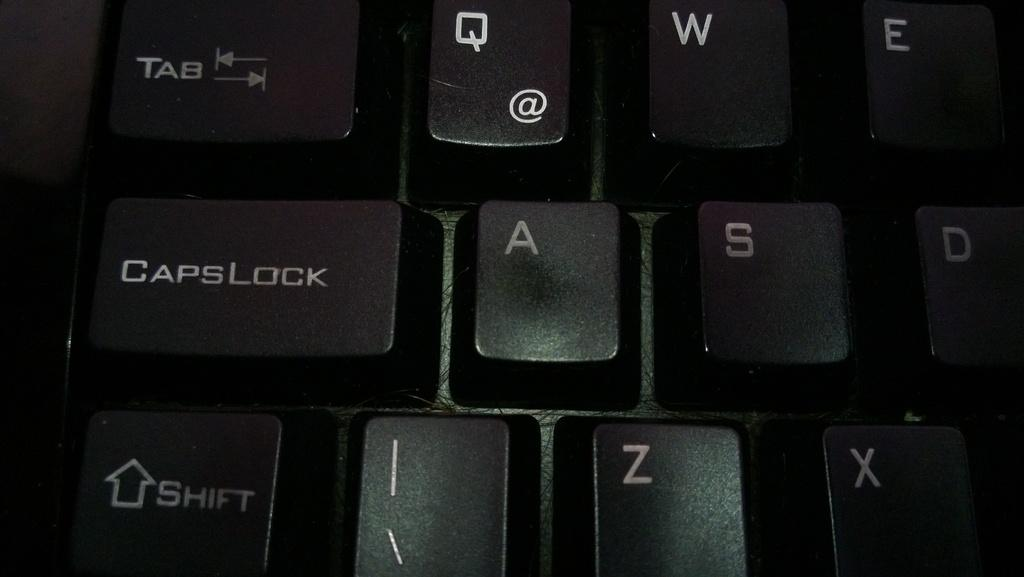<image>
Give a short and clear explanation of the subsequent image. Black computer keyboard with the keys Caps Lock and Shift being displayed 